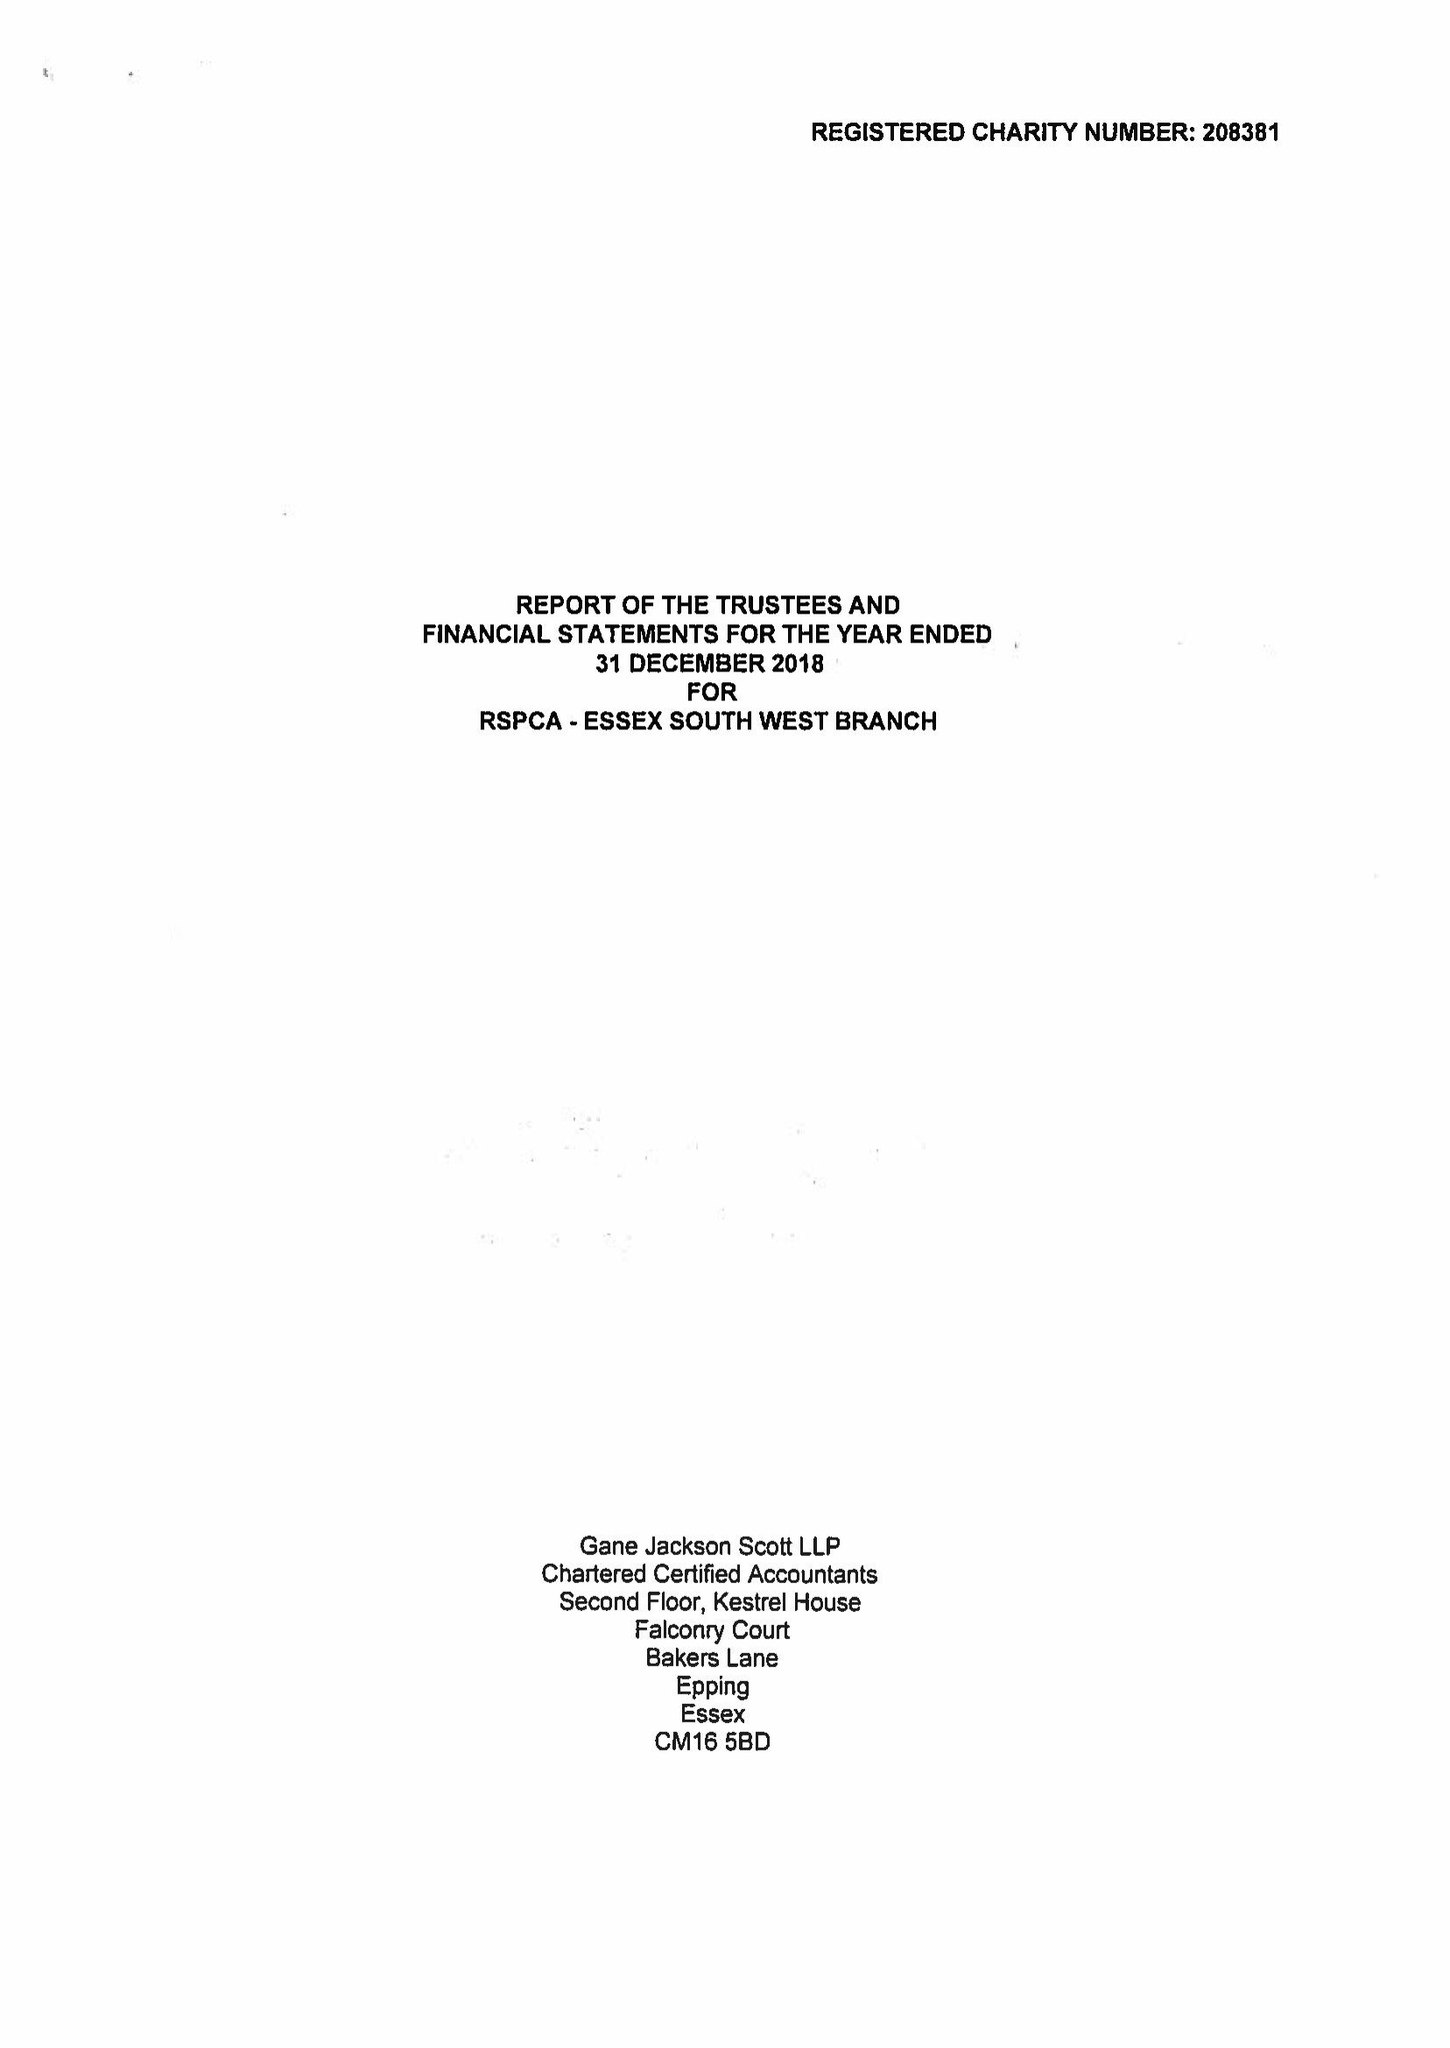What is the value for the charity_name?
Answer the question using a single word or phrase. Rspca - Essex South West Branch 